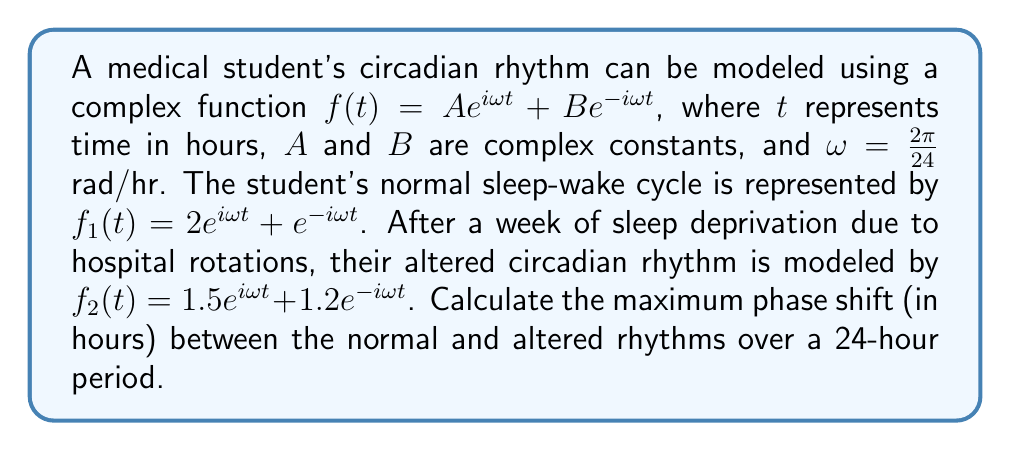What is the answer to this math problem? To solve this problem, we'll follow these steps:

1) The phase of each function at time $t$ is given by the argument of the complex number $f(t)$. We need to find the maximum difference between the arguments of $f_1(t)$ and $f_2(t)$ over a 24-hour period.

2) For a function of the form $f(t) = Ae^{i\omega t} + Be^{-i\omega t}$, the argument is given by:

   $\arg(f(t)) = \arctan\left(\frac{(A-B)\sin(\omega t)}{(A+B)\cos(\omega t)}\right)$

3) For $f_1(t)$:
   $\arg(f_1(t)) = \arctan\left(\frac{(2-1)\sin(\omega t)}{(2+1)\cos(\omega t)}\right) = \arctan\left(\frac{\sin(\omega t)}{3\cos(\omega t)}\right)$

4) For $f_2(t)$:
   $\arg(f_2(t)) = \arctan\left(\frac{(1.5-1.2)\sin(\omega t)}{(1.5+1.2)\cos(\omega t)}\right) = \arctan\left(\frac{0.3\sin(\omega t)}{2.7\cos(\omega t)}\right)$

5) The phase difference is:
   $\Delta\phi(t) = \arg(f_1(t)) - \arg(f_2(t))$
   $= \arctan\left(\frac{\sin(\omega t)}{3\cos(\omega t)}\right) - \arctan\left(\frac{0.3\sin(\omega t)}{2.7\cos(\omega t)}\right)$

6) The maximum phase difference occurs when $\sin(\omega t) = \pm 1$ and $\cos(\omega t) = 0$, i.e., at $t = 6$ or $t = 18$ hours.

7) At these points:
   $\Delta\phi_{max} = \arctan(\infty) - \arctan(\infty) = \frac{\pi}{2} - \frac{\pi}{2} = 0$

8) However, we need to consider the limits as we approach these points. As $t$ approaches 6 or 18 hours:
   $\lim_{t\to 6^-} \Delta\phi(t) = \frac{\pi}{2} - \arctan(\frac{1}{9}) \approx 1.4289$ radians
   $\lim_{t\to 6^+} \Delta\phi(t) = -\frac{\pi}{2} + \arctan(\frac{1}{9}) \approx -1.4289$ radians

9) The maximum phase shift is the larger of these absolute values, which is approximately 1.4289 radians.

10) To convert this to hours, we use the relation: 1 radian = $\frac{24}{2\pi}$ hours
    $1.4289 \cdot \frac{24}{2\pi} \approx 5.4574$ hours
Answer: The maximum phase shift between the normal and altered circadian rhythms is approximately 5.46 hours. 